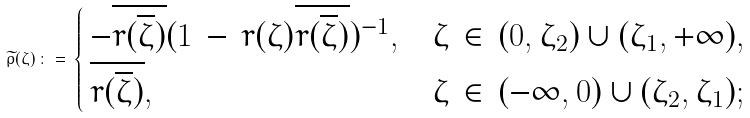Convert formula to latex. <formula><loc_0><loc_0><loc_500><loc_500>\widetilde { \rho } ( \zeta ) \, \colon = \, \begin{cases} \, - \overline { r ( \overline { \zeta } ) } ( 1 \, - \, r ( \zeta ) \overline { r ( \overline { \zeta } ) } ) ^ { - 1 } , & \text {$\zeta \, \in \, (0,\zeta_{2}) \cup (\zeta_{1},+\infty),$} \\ \, \overline { r ( \overline { \zeta } ) } , & \text {$\zeta \, \in \, (-\infty, 0) \cup (\zeta_{2},\zeta_{1});$} \end{cases}</formula> 